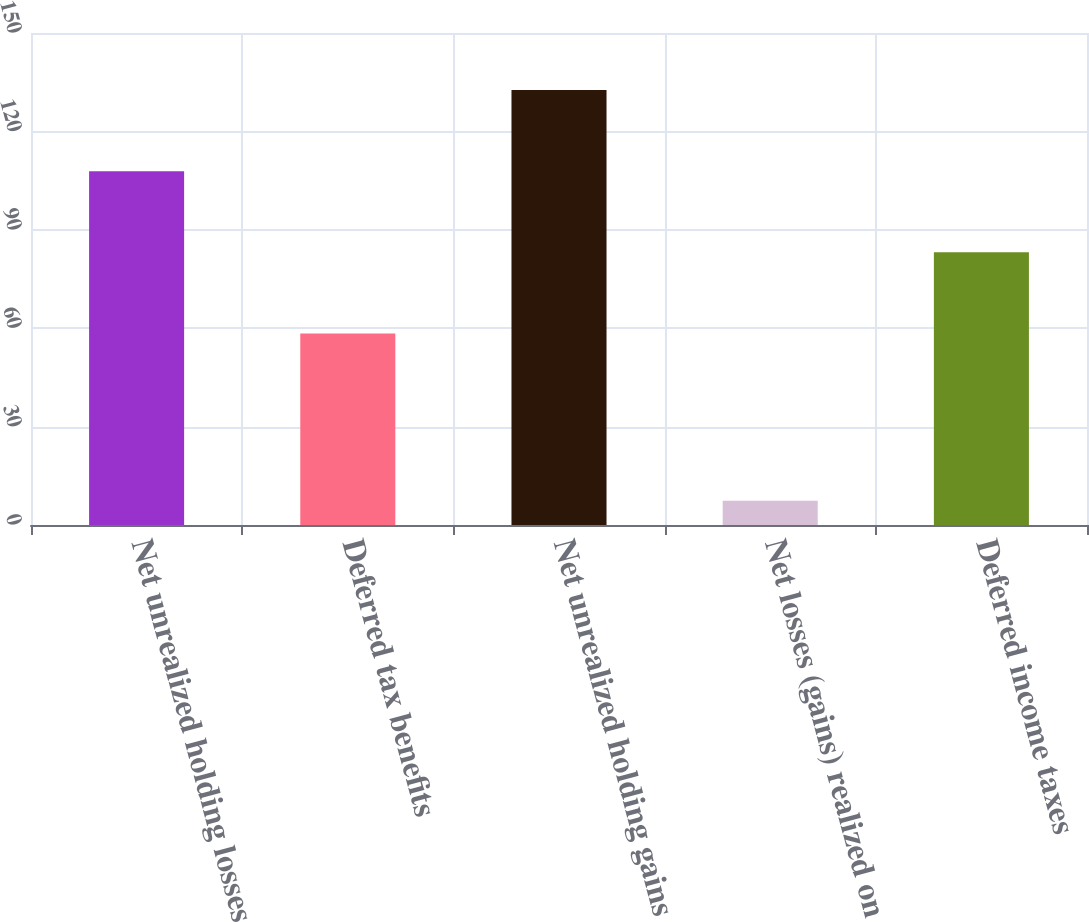Convert chart to OTSL. <chart><loc_0><loc_0><loc_500><loc_500><bar_chart><fcel>Net unrealized holding losses<fcel>Deferred tax benefits<fcel>Net unrealized holding gains<fcel>Net losses (gains) realized on<fcel>Deferred income taxes<nl><fcel>107.86<fcel>58.4<fcel>132.59<fcel>7.4<fcel>83.13<nl></chart> 